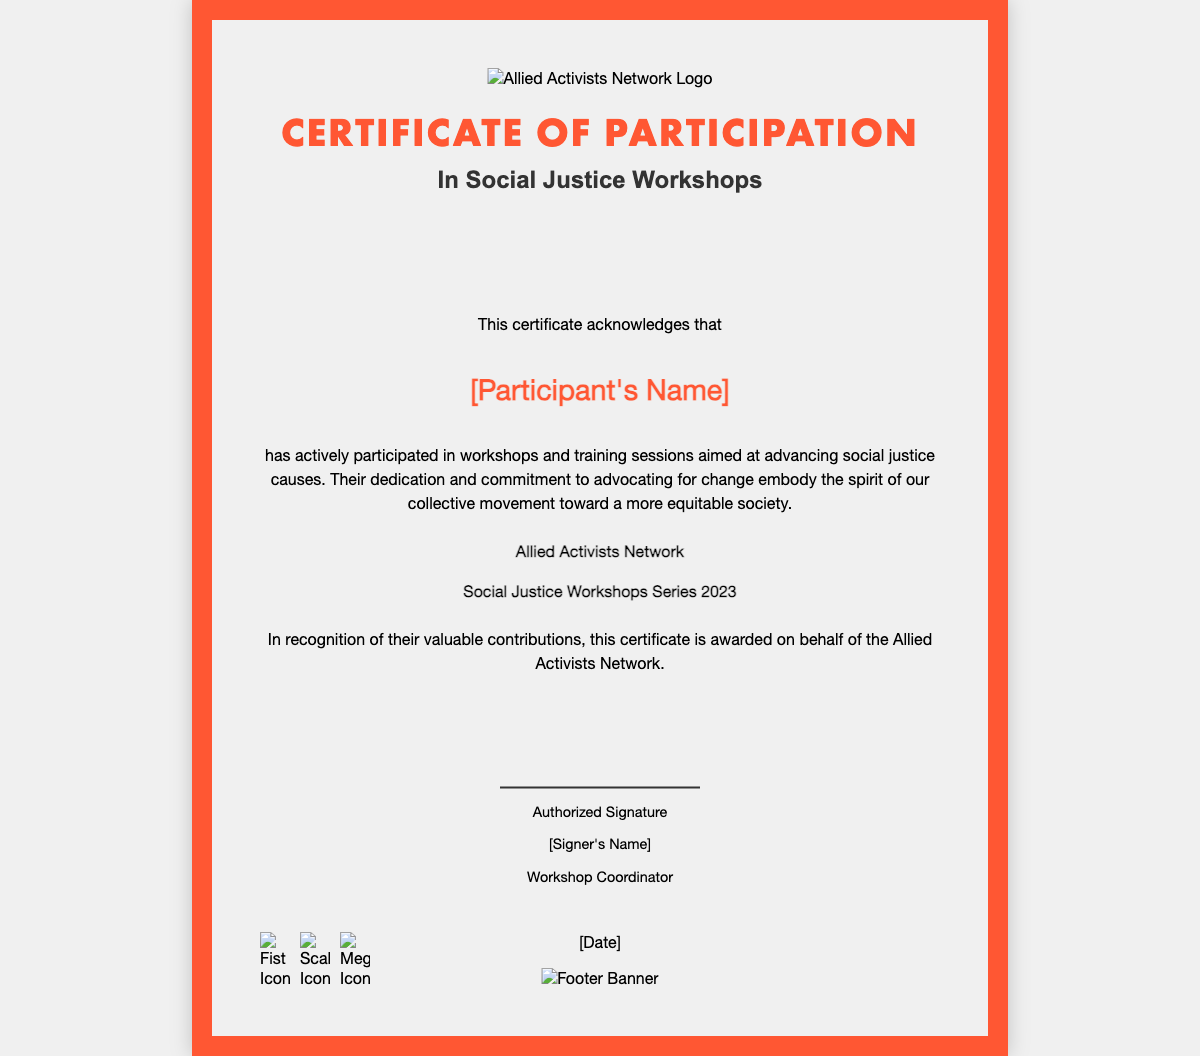What is the title of the certificate? The title of the certificate is prominently displayed at the top of the document as "Certificate of Participation".
Answer: Certificate of Participation Who is the participant named in the certificate? The participant’s name is expected to be filled in where it says "[Participant's Name]".
Answer: [Participant's Name] What type of workshops does this certificate acknowledge participation in? The certificate specifies that it recognizes participation in "Social Justice Workshops".
Answer: Social Justice Workshops What organization is issuing the certificate? The organization that is mentioned in the certificate as issuing it is identified as "Allied Activists Network".
Answer: Allied Activists Network In which year were the workshops held? The certificate confirms that the workshops took place in "2023".
Answer: 2023 What is the role of the signer in this document? The signer is identified in the signature section as the "Workshop Coordinator".
Answer: Workshop Coordinator What visual theme is used in the background of the certificate? The background image depicts themes related to social justice, indicated by the filename "bg_social_justice.jpg".
Answer: Social justice What is the purpose of this certificate? The certificate's primary purpose is to acknowledge active participation in efforts to advance social justice causes.
Answer: Acknowledge participation What icons are included at the bottom of the certificate? The icons represent activist symbols including a fist, scales, and a megaphone, suggesting themes of activism.
Answer: Fist, scales, megaphone 